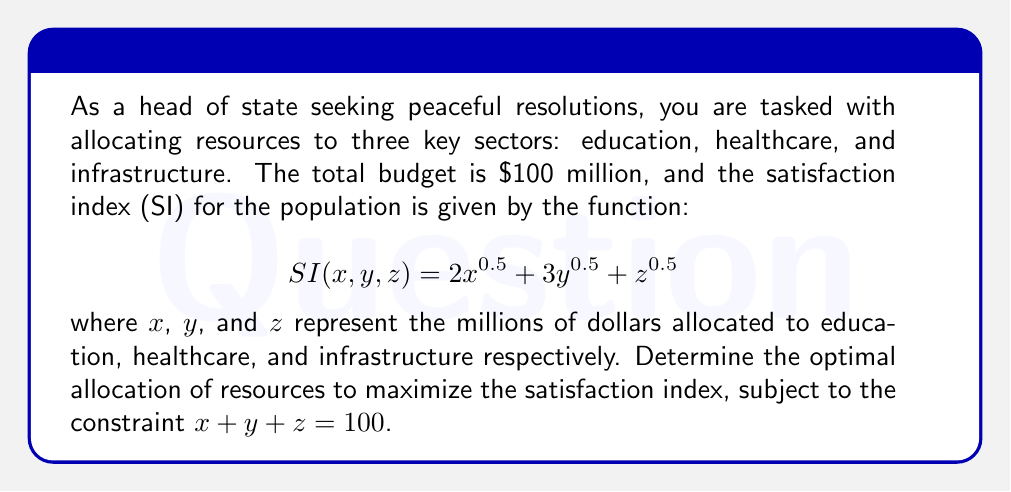Give your solution to this math problem. To solve this optimization problem with constraints, we'll use the method of Lagrange multipliers:

1) Define the Lagrangian function:
   $$L(x, y, z, \lambda) = 2x^{0.5} + 3y^{0.5} + z^{0.5} - \lambda(x + y + z - 100)$$

2) Take partial derivatives and set them equal to zero:
   $$\frac{\partial L}{\partial x} = x^{-0.5} - \lambda = 0$$
   $$\frac{\partial L}{\partial y} = \frac{3}{2}y^{-0.5} - \lambda = 0$$
   $$\frac{\partial L}{\partial z} = \frac{1}{2}z^{-0.5} - \lambda = 0$$
   $$\frac{\partial L}{\partial \lambda} = x + y + z - 100 = 0$$

3) From these equations, we can derive:
   $$x^{-0.5} = \frac{3}{2}y^{-0.5} = \frac{1}{2}z^{-0.5} = \lambda$$

4) This implies:
   $$x = 4y = 16z$$

5) Substituting into the constraint equation:
   $$x + y + z = 100$$
   $$16z + 4z + z = 100$$
   $$21z = 100$$
   $$z = \frac{100}{21} \approx 4.76$$

6) Now we can solve for $x$ and $y$:
   $$x = 16z = \frac{1600}{21} \approx 76.19$$
   $$y = 4z = \frac{400}{21} \approx 19.05$$

7) Verify that $x + y + z = 100$:
   $$\frac{1600}{21} + \frac{400}{21} + \frac{100}{21} = \frac{2100}{21} = 100$$

Therefore, the optimal allocation is approximately:
$x \approx 76.19$ million for education
$y \approx 19.05$ million for healthcare
$z \approx 4.76$ million for infrastructure
Answer: The optimal allocation to maximize the satisfaction index is:
Education: $\frac{1600}{21} \approx 76.19$ million
Healthcare: $\frac{400}{21} \approx 19.05$ million
Infrastructure: $\frac{100}{21} \approx 4.76$ million 